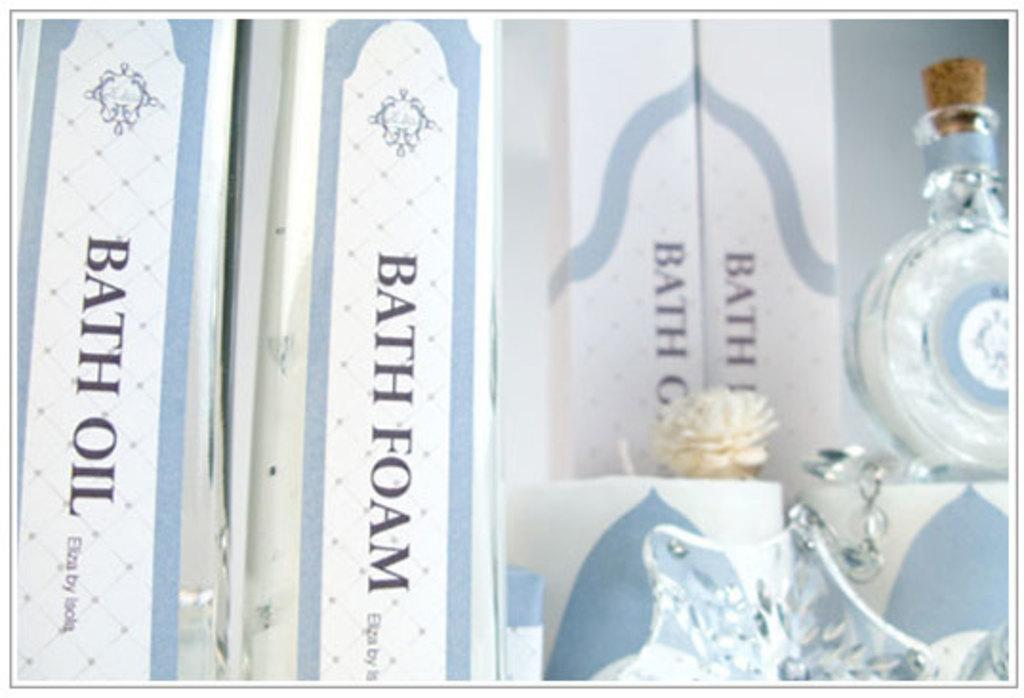<image>
Provide a brief description of the given image. Bottle next to a box that says "Bath Oil". 